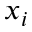Convert formula to latex. <formula><loc_0><loc_0><loc_500><loc_500>x _ { i }</formula> 